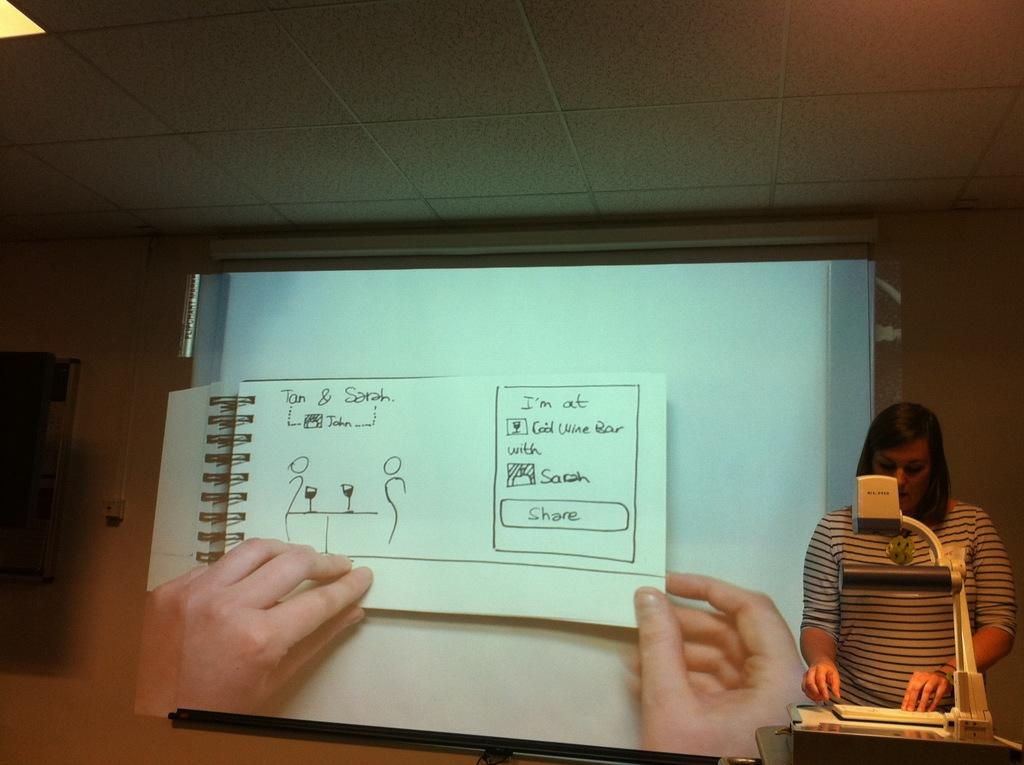<image>
Summarize the visual content of the image. A spiral book with a page with "Tan & Sarah" on the upper left side. 